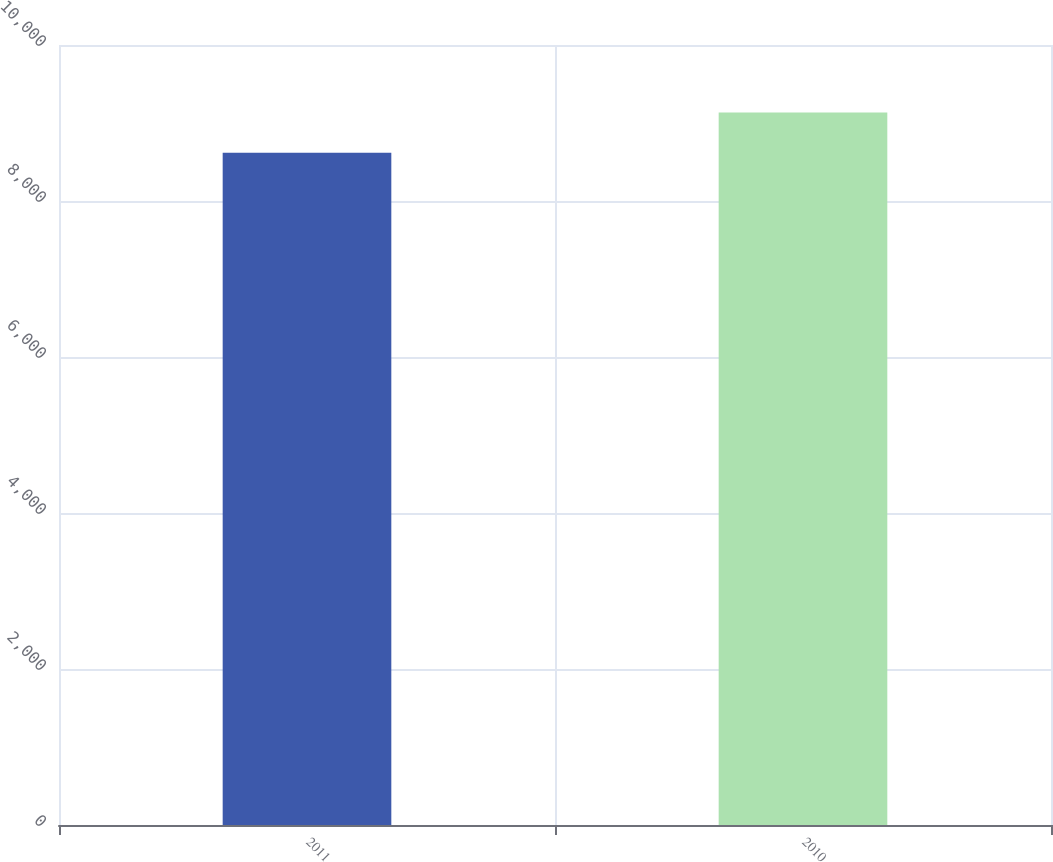<chart> <loc_0><loc_0><loc_500><loc_500><bar_chart><fcel>2011<fcel>2010<nl><fcel>8617<fcel>9135<nl></chart> 